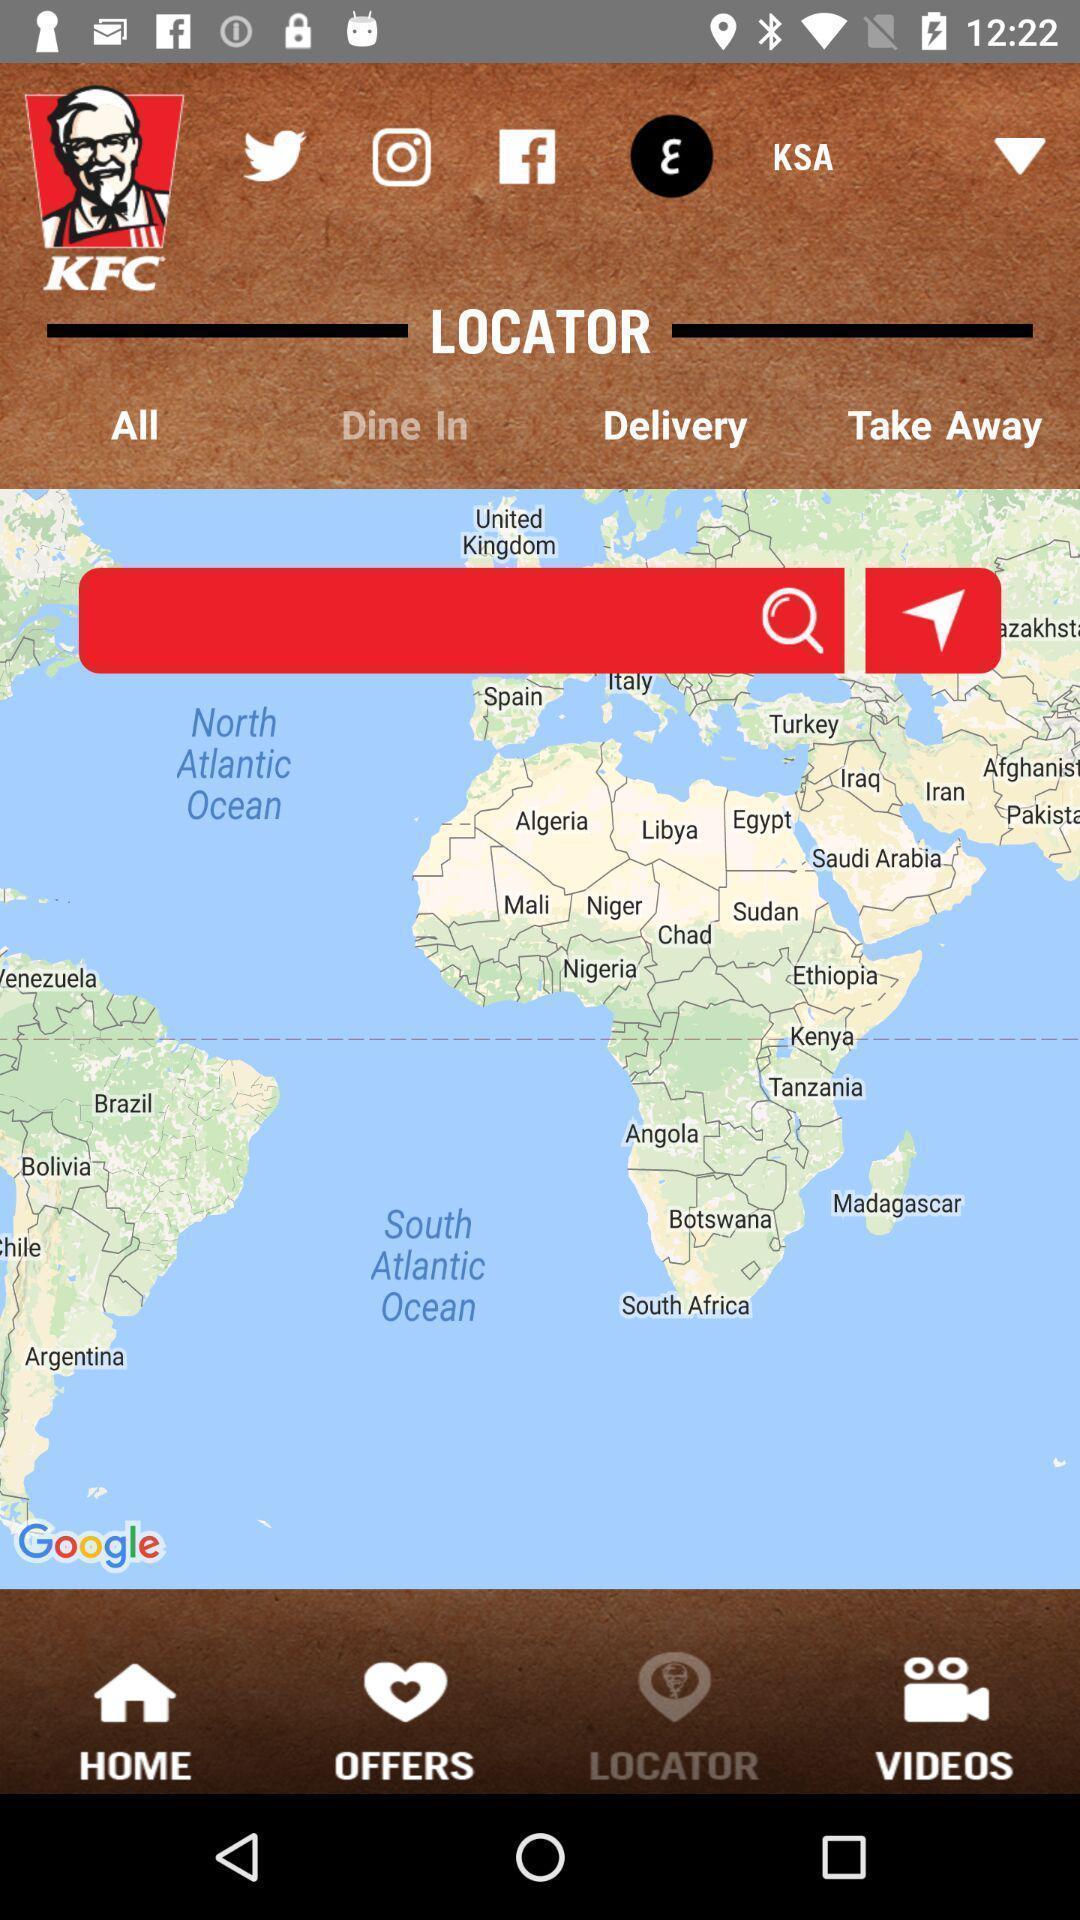Summarize the main components in this picture. Screen displaying the search field to find location in map. 